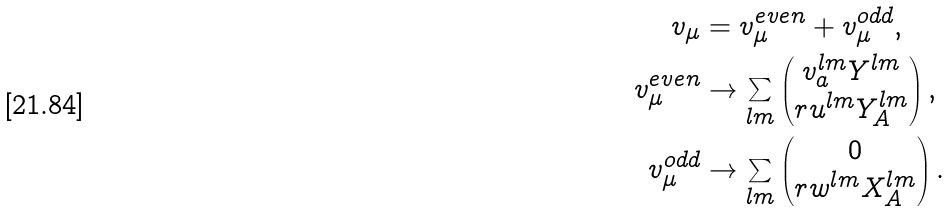Convert formula to latex. <formula><loc_0><loc_0><loc_500><loc_500>v _ { \mu } & = v _ { \mu } ^ { e v e n } + v _ { \mu } ^ { o d d } , \\ v _ { \mu } ^ { e v e n } & \to \sum _ { l m } \begin{pmatrix} v _ { a } ^ { l m } Y ^ { l m } \\ r u ^ { l m } Y _ { A } ^ { l m } \end{pmatrix} , \\ v _ { \mu } ^ { o d d } & \to \sum _ { l m } \begin{pmatrix} 0 \\ r w ^ { l m } X _ { A } ^ { l m } \end{pmatrix} .</formula> 